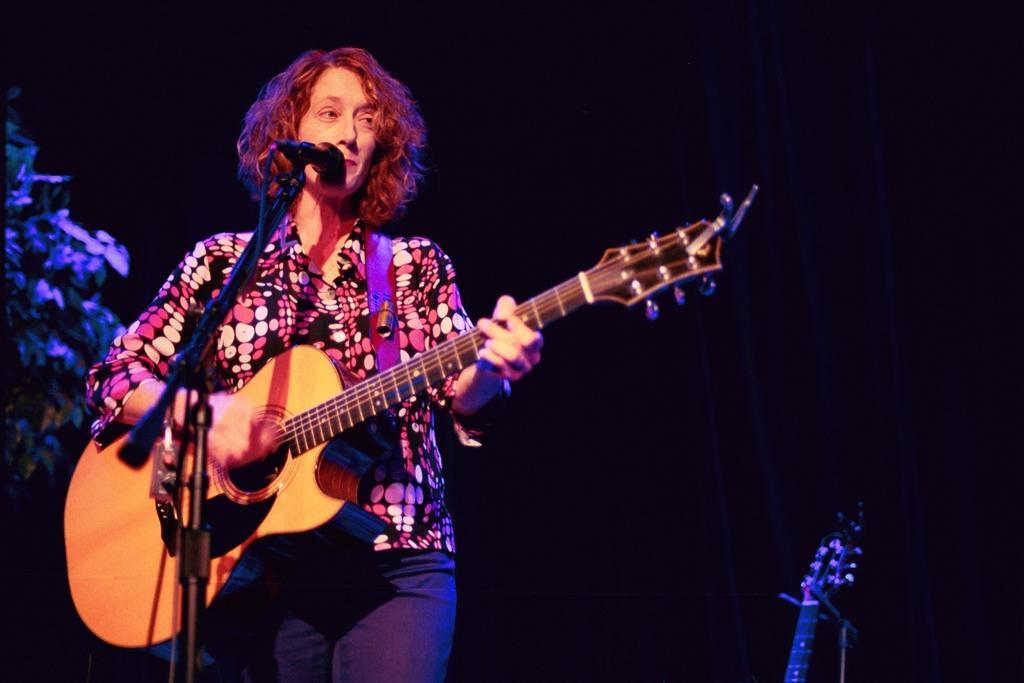Can you describe this image briefly? In this image, woman is playing a guitar in-front of microphone. Here we can see stand, wire. And background, we can see some cloth. Left side, there is a plant. At the bottom, There is an another musical instrument. 